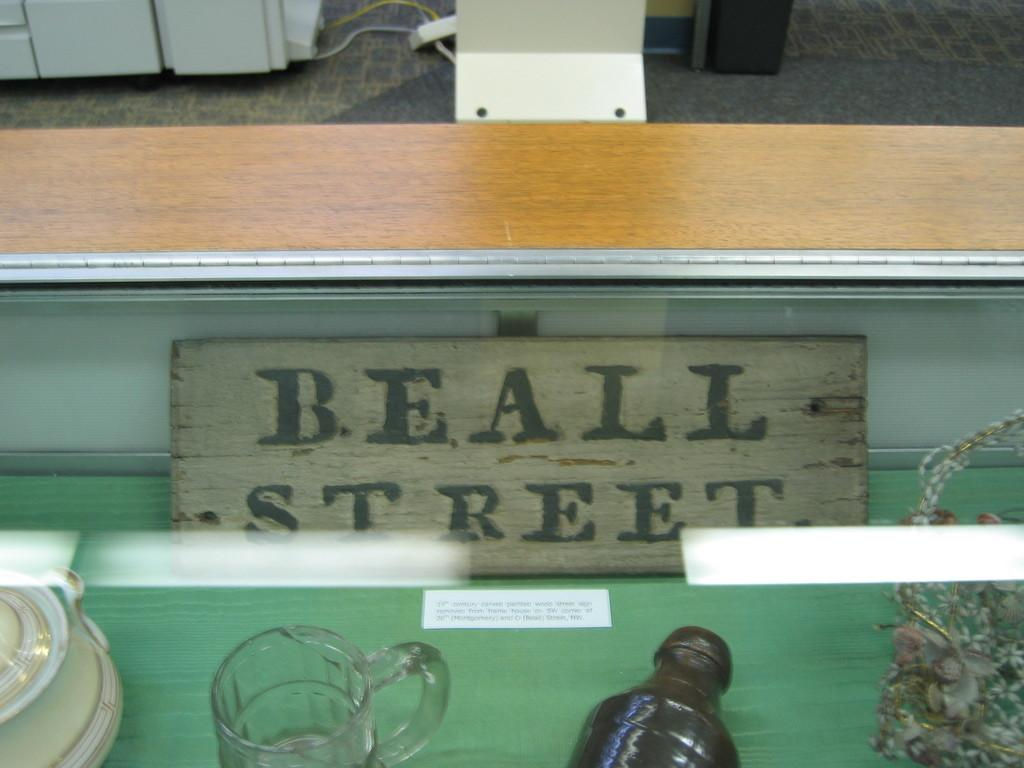Provide a one-sentence caption for the provided image. in the back of a display case is a sign that says BEALL STREET. 